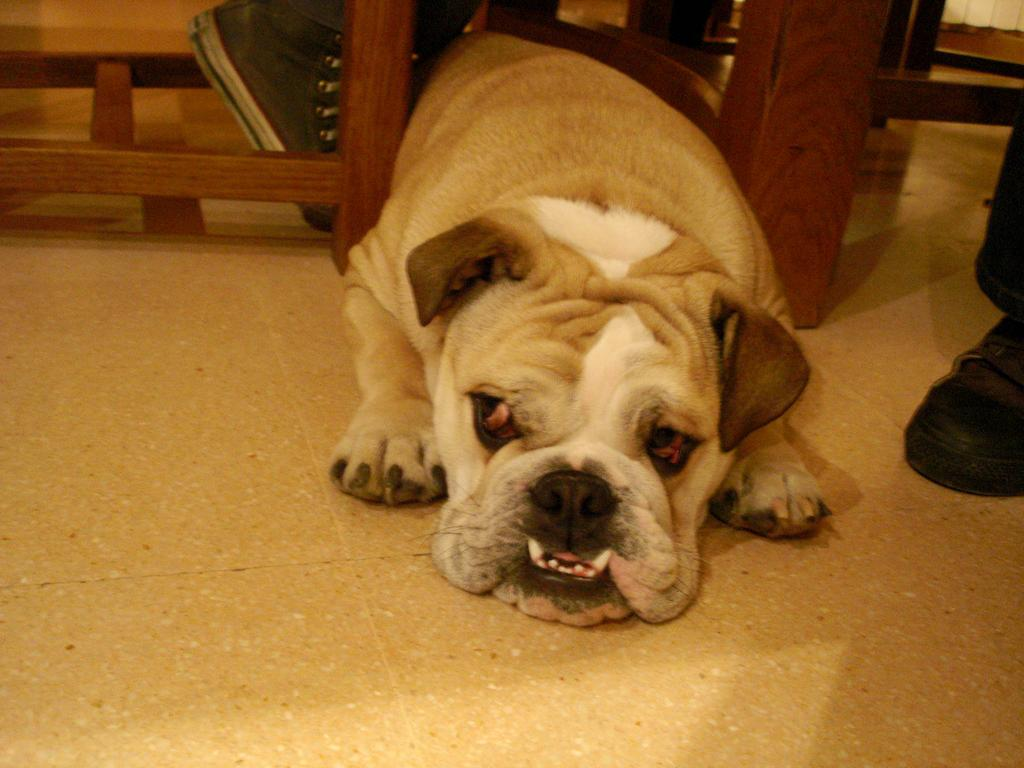What is the main subject in the middle of the image? There is a dog laying on the floor in the middle of the image. What can be seen beside the dog? There is a wooden object beside the dog. Where is the person located in the image? There is a person wearing a shoe on the right side of the image. What type of grain is being harvested by the doll in the image? There is no doll present in the image, and therefore no doll harvesting grain. 